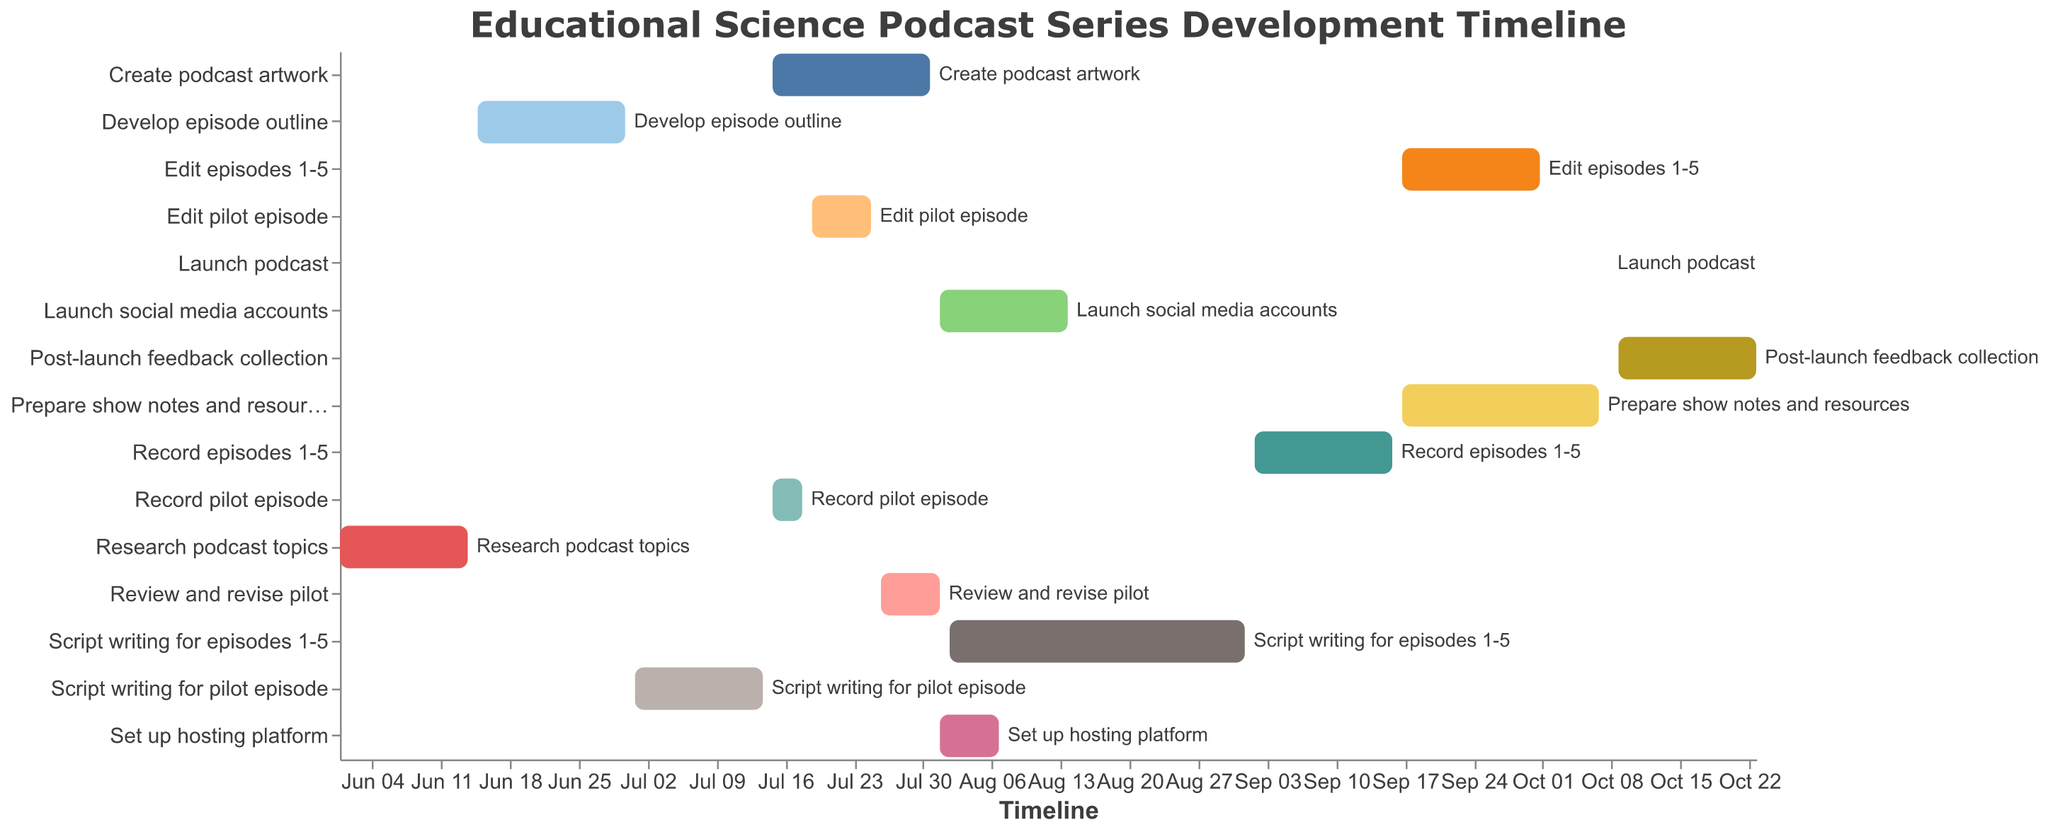When does the project start and end? According to the Gantt Chart, the timeline shows the project's activities starting from the earliest to the latest dates. The earliest start date visible in the chart is June 1, 2023, and the latest end date visible is October 23, 2023.
Answer: June 1, 2023 - October 23, 2023 Which task takes the longest time to complete in the project timeline? To find the task with the longest duration, examine the gaps between the start and end dates for each task. "Script writing for episodes 1-5" starts on August 2 and ends on September 1, thus spanning 31 days, making it the longest task.
Answer: Script writing for episodes 1-5 How many tasks are scheduled to end on August 1, 2023? Look at the chart and identify tasks with the end date of August 1, 2023. "Review and revise pilot" ends on August 1, 2023.
Answer: One task When is the pilot episode recording scheduled to start and end? Check the time indicated for "Record pilot episode." The Gantt chart shows that the task begins on July 15, 2023, and ends on July 18, 2023.
Answer: July 15, 2023 - July 18, 2023 Which tasks overlap with the task "Script writing for pilot episode"? Look at "Script writing for pilot episode" which runs from July 1, 2023, to July 14, 2023. Identify any tasks that fall within this timeframe. No other tasks overlap directly within these exact dates.
Answer: None How many tasks occur after the podcast launch date? The Gantt chart indicates that the podcast launch is on October 8, 2023. "Post-launch feedback collection" starts on October 9, 2023, which is the only task post-launch.
Answer: One task What tasks are scheduled during July 2023? To find tasks for July 2023, look for bars that span any date in this month. These include "Script writing for pilot episode," "Record pilot episode," "Edit pilot episode," "Review and revise pilot," and "Create podcast artwork".
Answer: Five tasks Is there any task with the same start and end date? Look at each task's start and end dates. The "Launch podcast" task is the only task with the start and end date being the same, which is October 8, 2023.
Answer: Yes, Launch podcast Which two tasks have the start date of July 15, 2023? Examine the chart and find tasks starting on July 15, 2023. These are "Record pilot episode" and "Create podcast artwork".
Answer: Record pilot episode and Create podcast artwork When does the task "Edit episodes 1-5" begin and end, and how long does it take to complete? The task "Edit episodes 1-5" starts on September 17, 2023, and ends on October 1, 2023. The duration can be calculated by counting the days between the start and end dates, resulting in 15 days.
Answer: September 17, 2023 - October 1, 2023, 15 days 